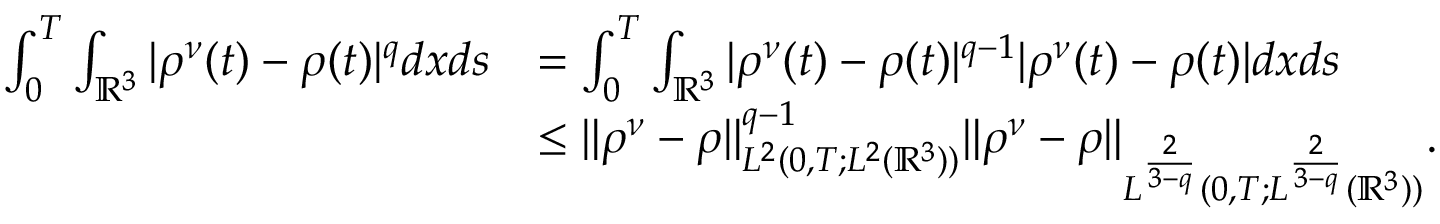<formula> <loc_0><loc_0><loc_500><loc_500>\begin{array} { r l } { \int _ { 0 } ^ { T } \int _ { \mathbb { R } ^ { 3 } } | \rho ^ { \nu } ( t ) - \rho ( t ) | ^ { q } d x d s } & { = \int _ { 0 } ^ { T } \int _ { \mathbb { R } ^ { 3 } } | \rho ^ { \nu } ( t ) - \rho ( t ) | ^ { q - 1 } | \rho ^ { \nu } ( t ) - \rho ( t ) | d x d s } \\ & { \leq \| \rho ^ { \nu } - \rho \| _ { L ^ { 2 } ( 0 , T ; L ^ { 2 } ( \mathbb { R } ^ { 3 } ) ) } ^ { q - 1 } \| \rho ^ { \nu } - \rho \| _ { L ^ { \frac { 2 } { 3 - q } } ( 0 , T ; L ^ { \frac { 2 } { 3 - q } } ( \mathbb { R } ^ { 3 } ) ) } . } \end{array}</formula> 